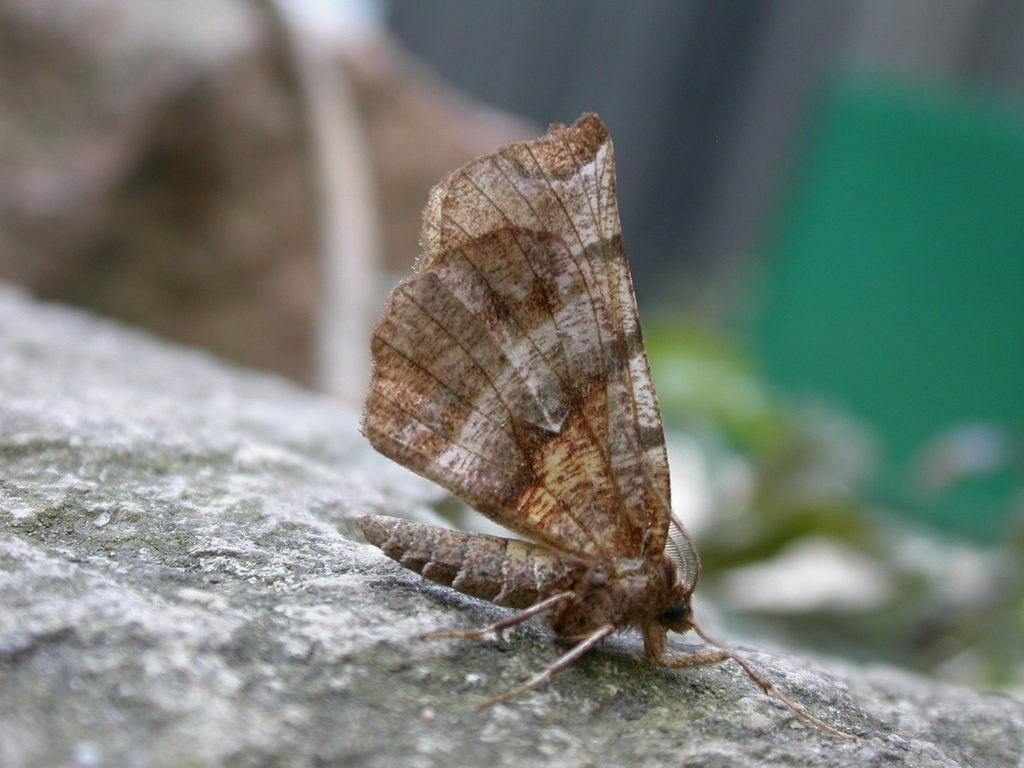What is the main subject of the image? There is a butterfly in the image. Where is the butterfly located? The butterfly is on a surface. Can you describe the background of the image? The background of the image is blurred. What type of distribution system is used for the bell in the image? There is no bell present in the image, so it is not possible to determine the type of distribution system used. 